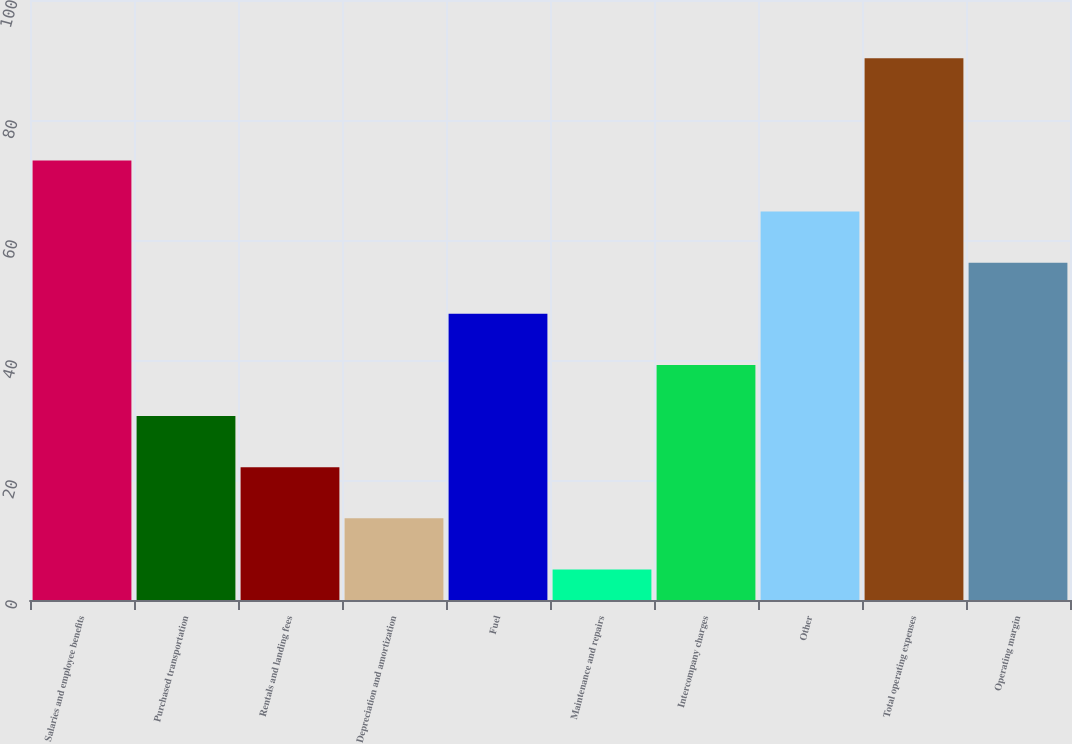<chart> <loc_0><loc_0><loc_500><loc_500><bar_chart><fcel>Salaries and employee benefits<fcel>Purchased transportation<fcel>Rentals and landing fees<fcel>Depreciation and amortization<fcel>Fuel<fcel>Maintenance and repairs<fcel>Intercompany charges<fcel>Other<fcel>Total operating expenses<fcel>Operating margin<nl><fcel>73.26<fcel>30.66<fcel>22.14<fcel>13.62<fcel>47.7<fcel>5.1<fcel>39.18<fcel>64.74<fcel>90.3<fcel>56.22<nl></chart> 